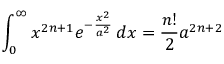Convert formula to latex. <formula><loc_0><loc_0><loc_500><loc_500>\int _ { 0 } ^ { \infty } x ^ { 2 n + 1 } e ^ { - { \frac { x ^ { 2 } } { a ^ { 2 } } } } \, d x = { \frac { n ! } { 2 } } a ^ { 2 n + 2 }</formula> 